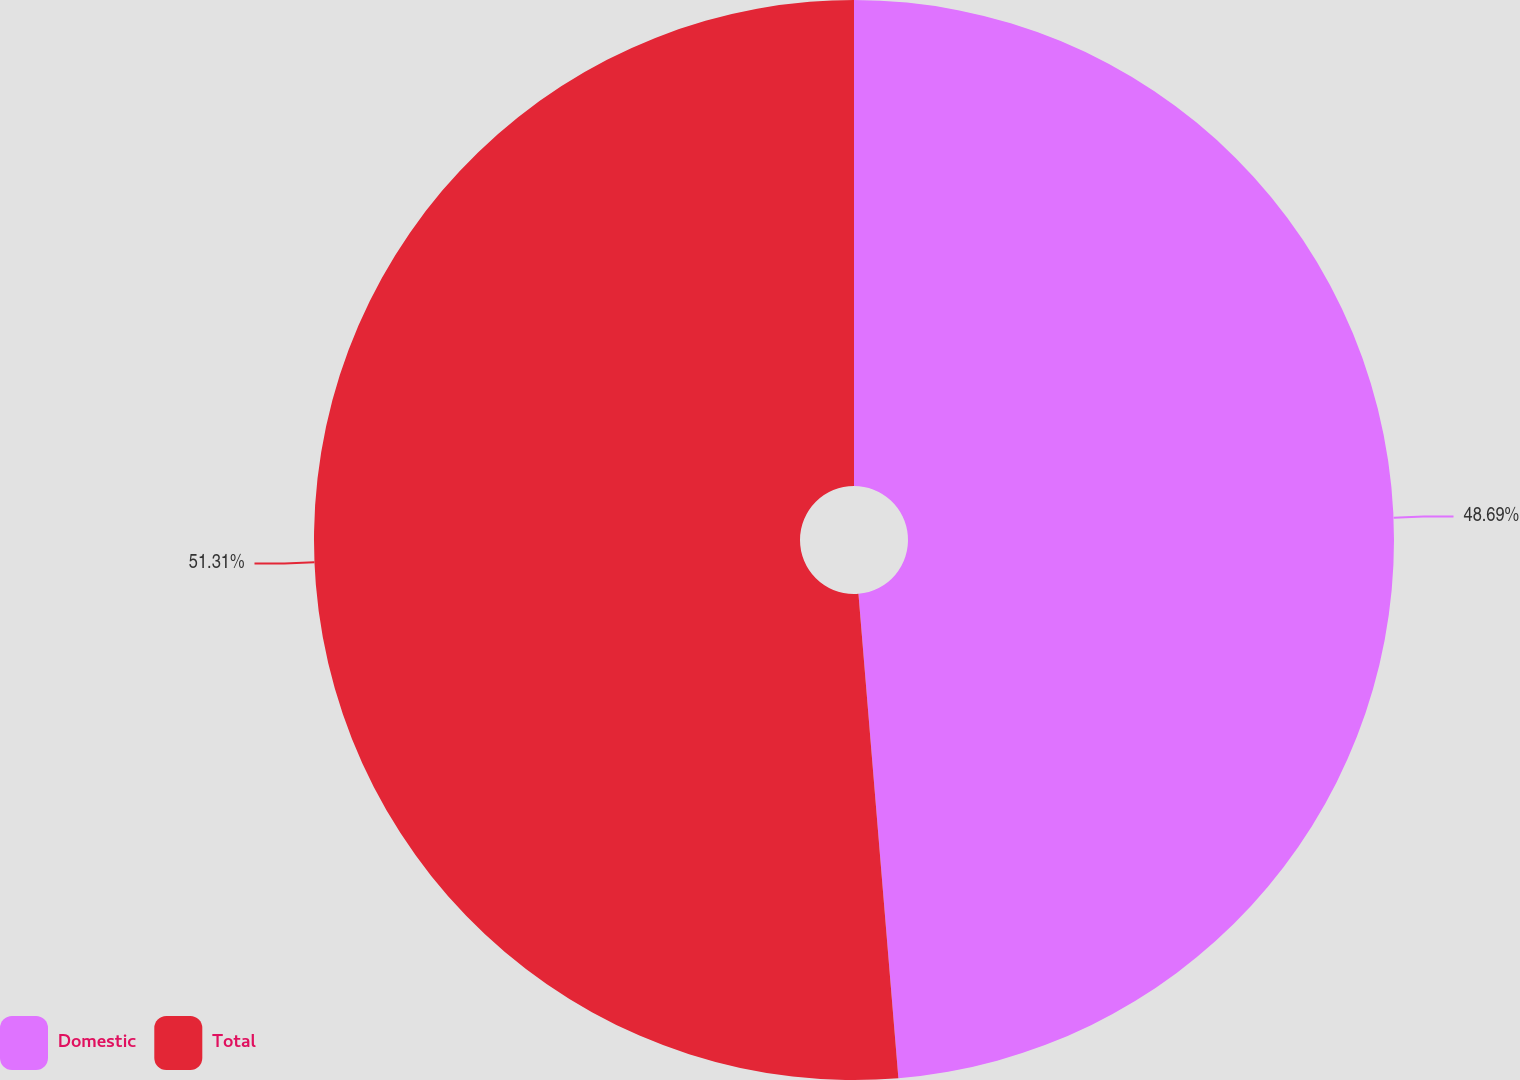Convert chart to OTSL. <chart><loc_0><loc_0><loc_500><loc_500><pie_chart><fcel>Domestic<fcel>Total<nl><fcel>48.69%<fcel>51.31%<nl></chart> 